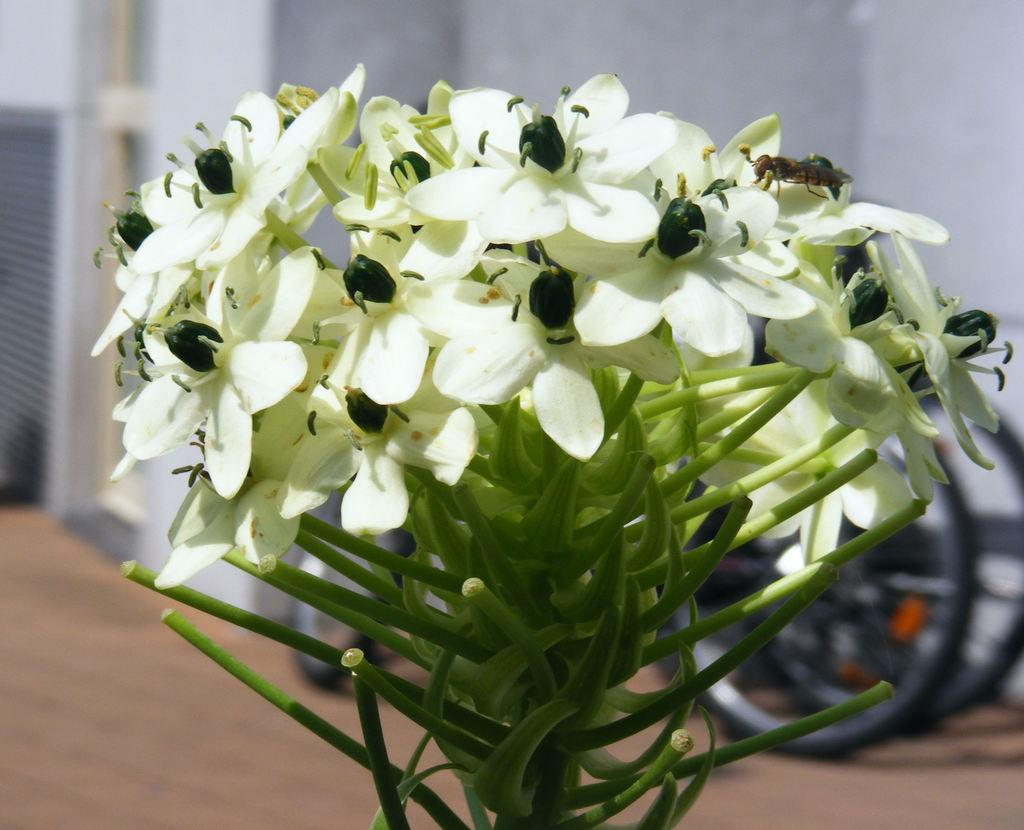What type of living organism is present in the image? There is a plant in the image. What specific feature of the plant is mentioned? The plant has flowers. Are there any other living organisms interacting with the plant? Yes, there is an insect on one of the flowers. What can be seen in the background of the image? There is a wall in the background of the image. What type of prose can be heard being read by the plant in the image? There is no indication in the image that the plant is reading or producing any prose. 